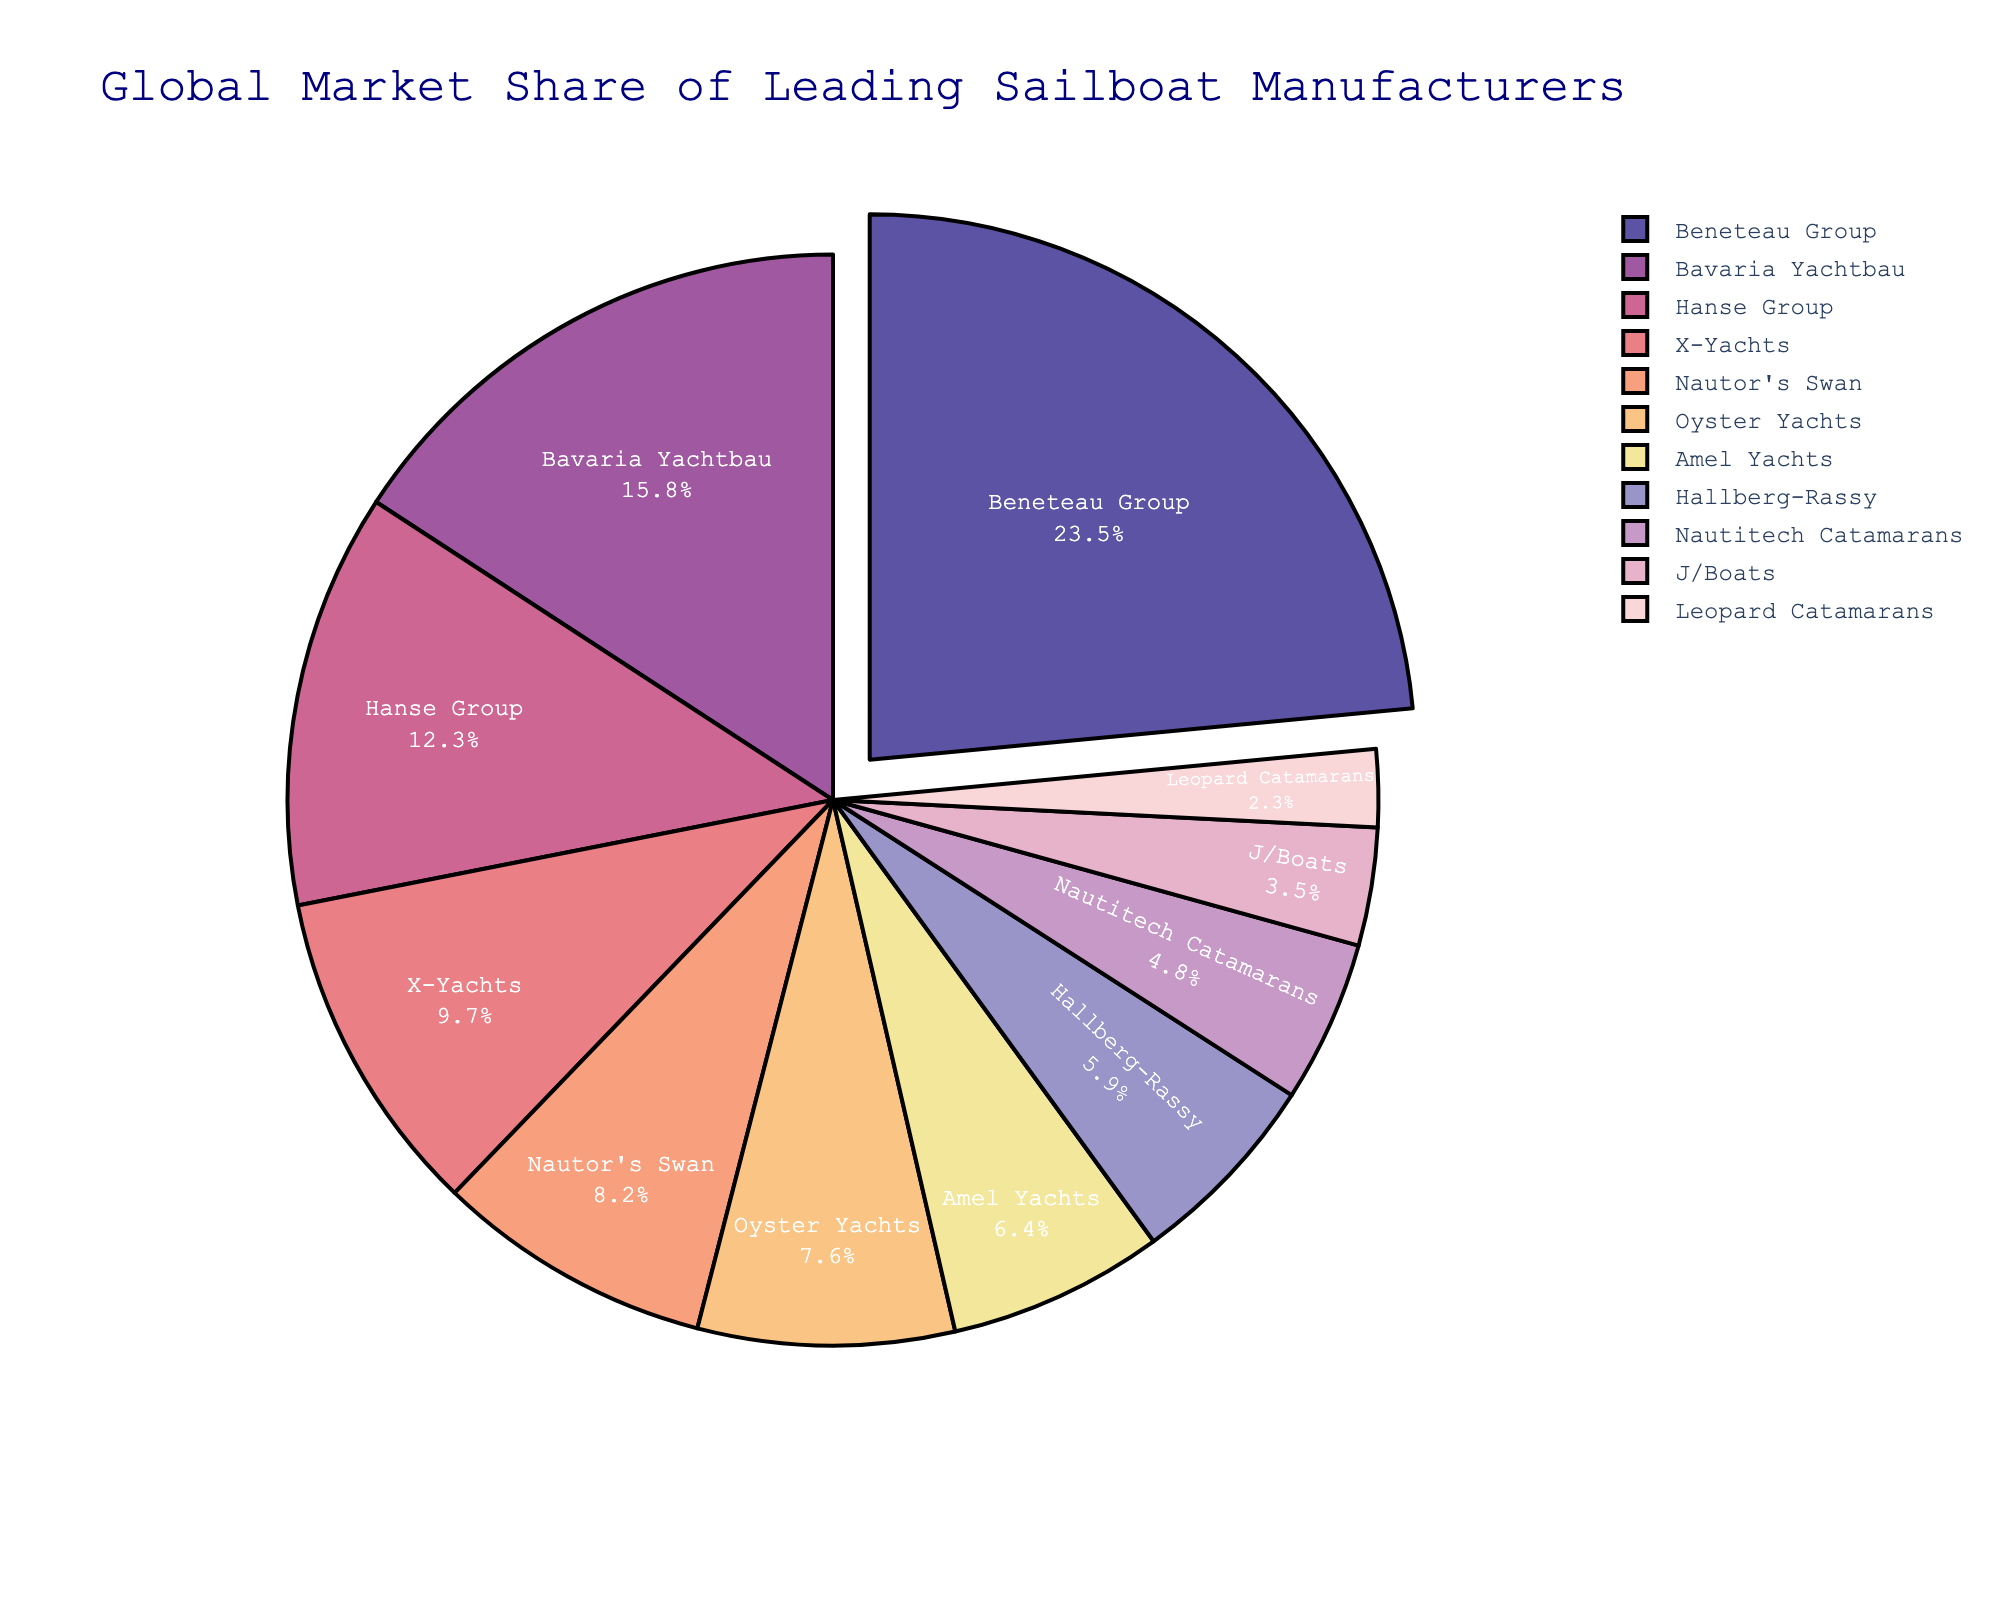Which manufacturer has the largest market share? First, look at the slice that takes up the largest portion of the pie chart. The label for this section will indicate the manufacturer with the largest market share.
Answer: Beneteau Group What's the combined market share of the top three manufacturers? Identify the top three slices by looking at the three largest portions and add their percentages. For Beneteau Group (23.5%), Bavaria Yachtbau (15.8%), and Hanse Group (12.3%), the sum is 23.5 + 15.8 + 12.3 = 51.6%.
Answer: 51.6% How does the market share of Bavaria Yachtbau compare to that of Beneteau Group? Compare the percentage values on the pie chart. Beneteau Group has a market share of 23.5%, while Bavaria Yachtbau has 15.8%. The difference is 23.5 - 15.8 = 7.7%. Therefore, Beneteau Group has a 7.7% higher market share than Bavaria Yachtbau.
Answer: Beneteau Group is 7.7% higher Which manufacturer has a market share just below 10%? Find the slices corresponding to manufacturers with market shares close to 10%. The label for the slice with a value just below 10% is X-Yachts (9.7%).
Answer: X-Yachts Is there any manufacturer that has a market share greater than 20%? Look at the pie chart and find the slices labeled with percentages over 20%. Only Beneteau Group has a market share of 23.5%.
Answer: Yes, Beneteau Group What's the total market share of manufacturers with less than 10% market share? Identify the manufacturers whose market shares are below 10% and sum their percentages: X-Yachts (9.7%), Nautor's Swan (8.2%), Oyster Yachts (7.6%), Amel Yachts (6.4%), Hallberg-Rassy (5.9%), Nautitech Catamarans (4.8%), J/Boats (3.5%), Leopard Catamarans (2.3%). The total is 9.7 + 8.2 + 7.6 + 6.4 + 5.9 + 4.8 + 3.5 + 2.3 = 48.4%.
Answer: 48.4% Which manufacturer has a market share closest to the average market share? Calculate the average market share by summing all market shares and dividing by the number of manufacturers: (23.5 + 15.8 + 12.3 + 9.7 + 8.2 + 7.6 + 6.4 + 5.9 + 4.8 + 3.5 + 2.3) / 11 ≈ 9.96%. Then, identify the manufacturer whose market share is closest to this average, which is X-Yachts with 9.7%.
Answer: X-Yachts 